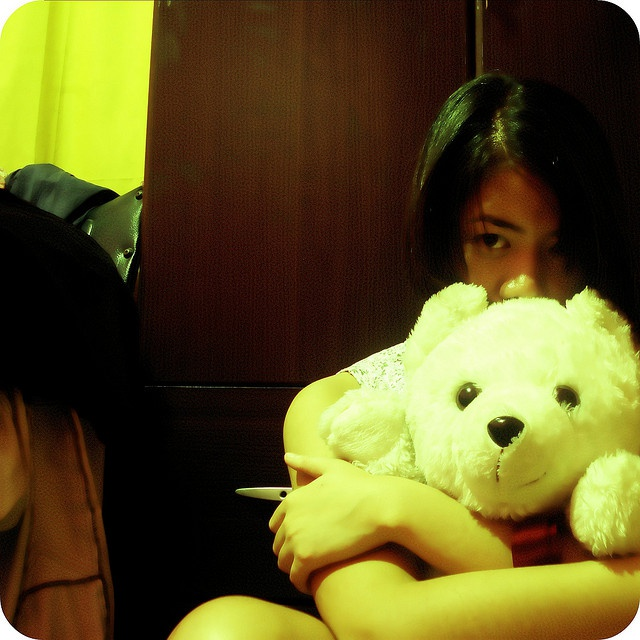Describe the objects in this image and their specific colors. I can see teddy bear in white, khaki, olive, and lightyellow tones, people in white, black, maroon, olive, and brown tones, and scissors in white, olive, and black tones in this image. 